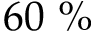<formula> <loc_0><loc_0><loc_500><loc_500>6 0 \ \%</formula> 